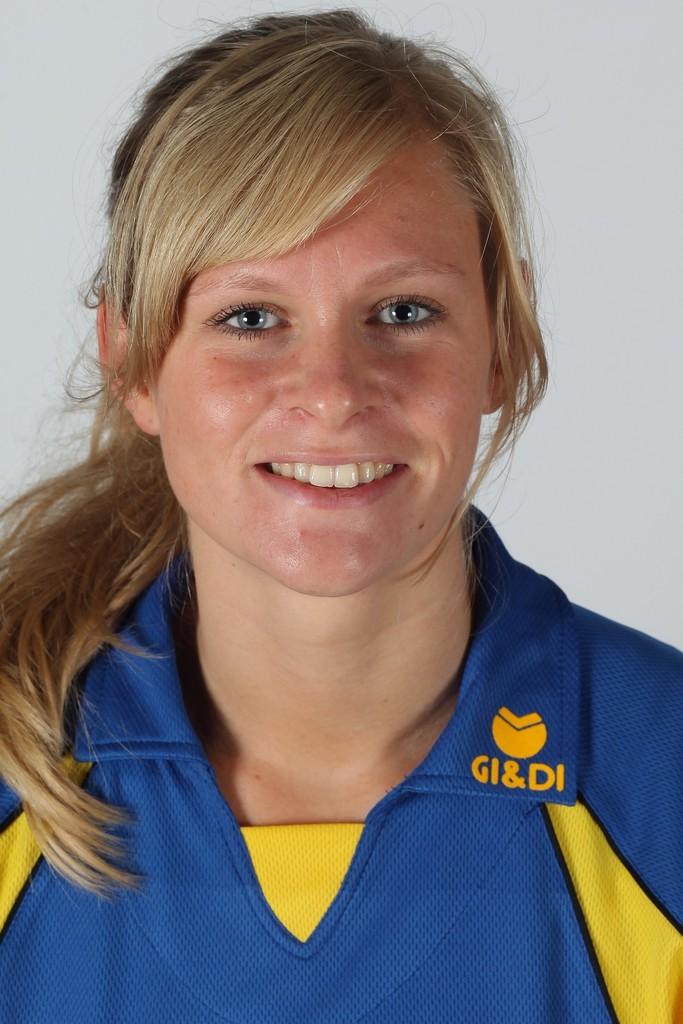What does it say below the symbol on this person's shirt collar?
Provide a short and direct response. Gi&di. 